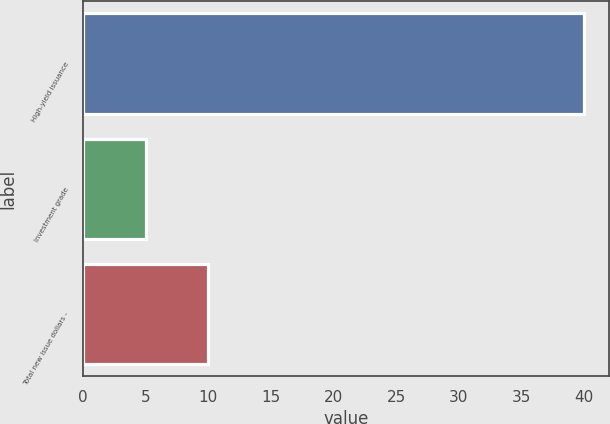Convert chart to OTSL. <chart><loc_0><loc_0><loc_500><loc_500><bar_chart><fcel>High-yield issuance<fcel>Investment grade<fcel>Total new issue dollars -<nl><fcel>40<fcel>5<fcel>10<nl></chart> 